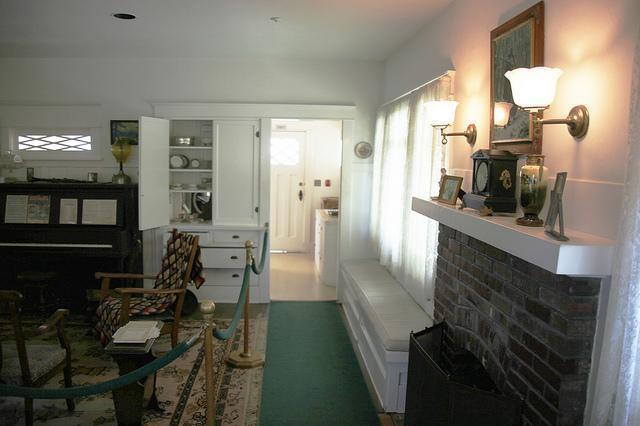How many chairs can be seen?
Give a very brief answer. 2. 